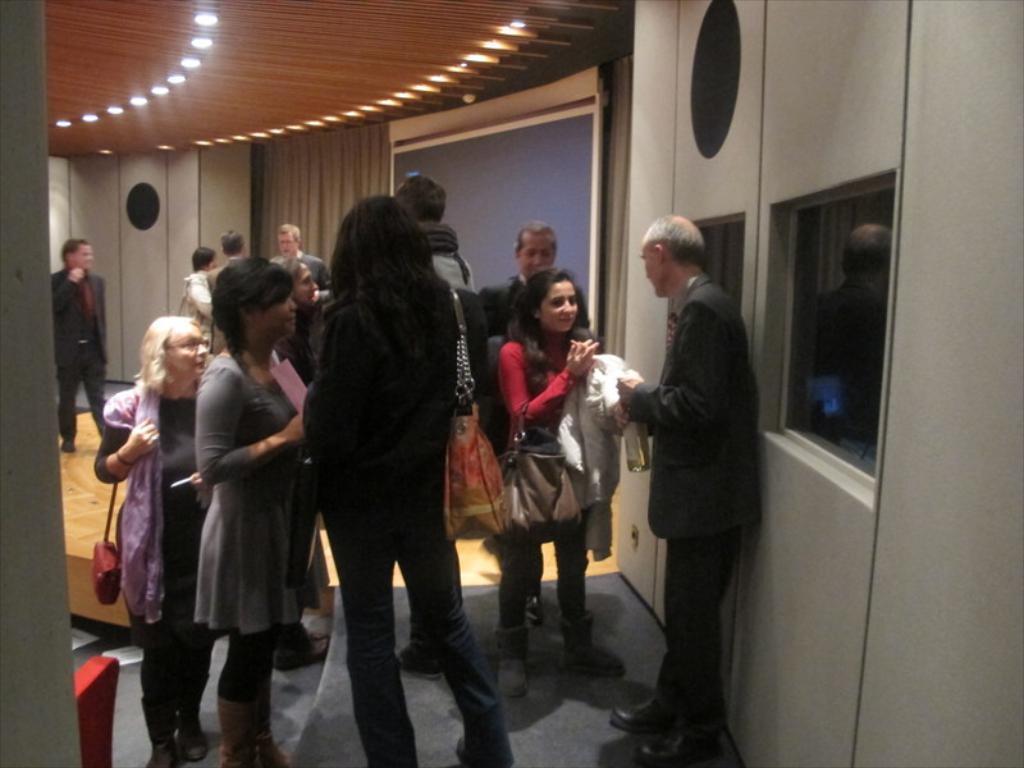In one or two sentences, can you explain what this image depicts? This is an inside view. Here I can see many people are standing on the floor. On the right side there is a wall and two glass windows. In the background there is a screen and a curtain. At the top of the image there are few lights to the roof. 